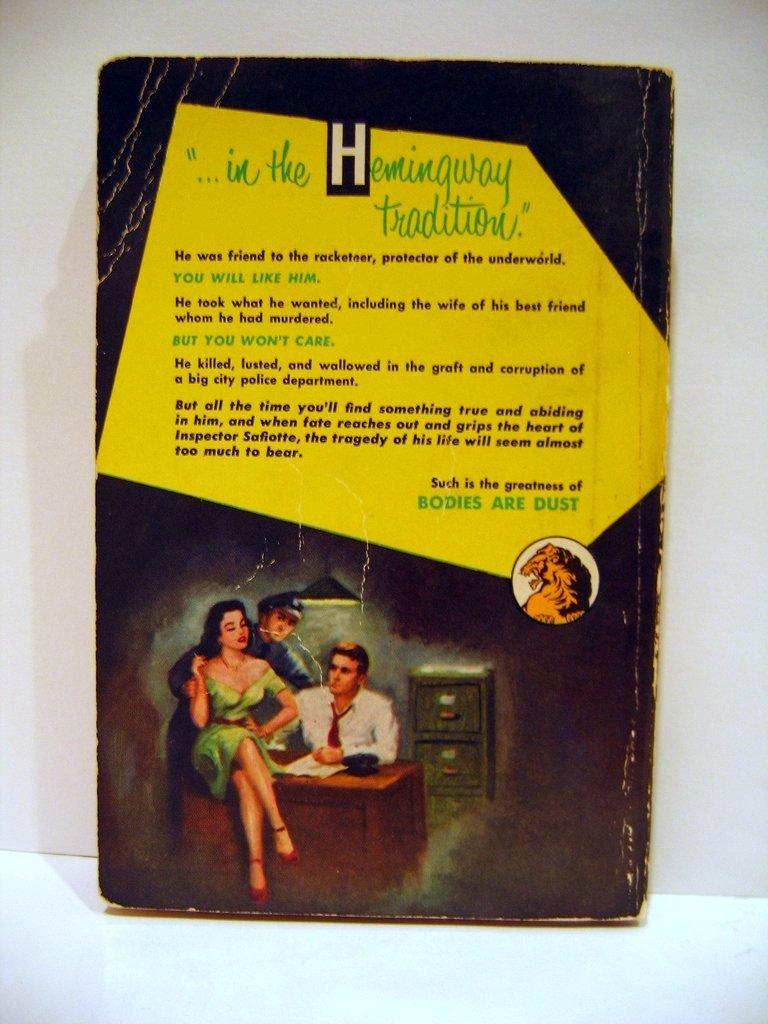<image>
Summarize the visual content of the image. The back of a book talks about the book, stating that Bodies are Dust 